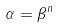<formula> <loc_0><loc_0><loc_500><loc_500>\alpha = \beta ^ { n }</formula> 